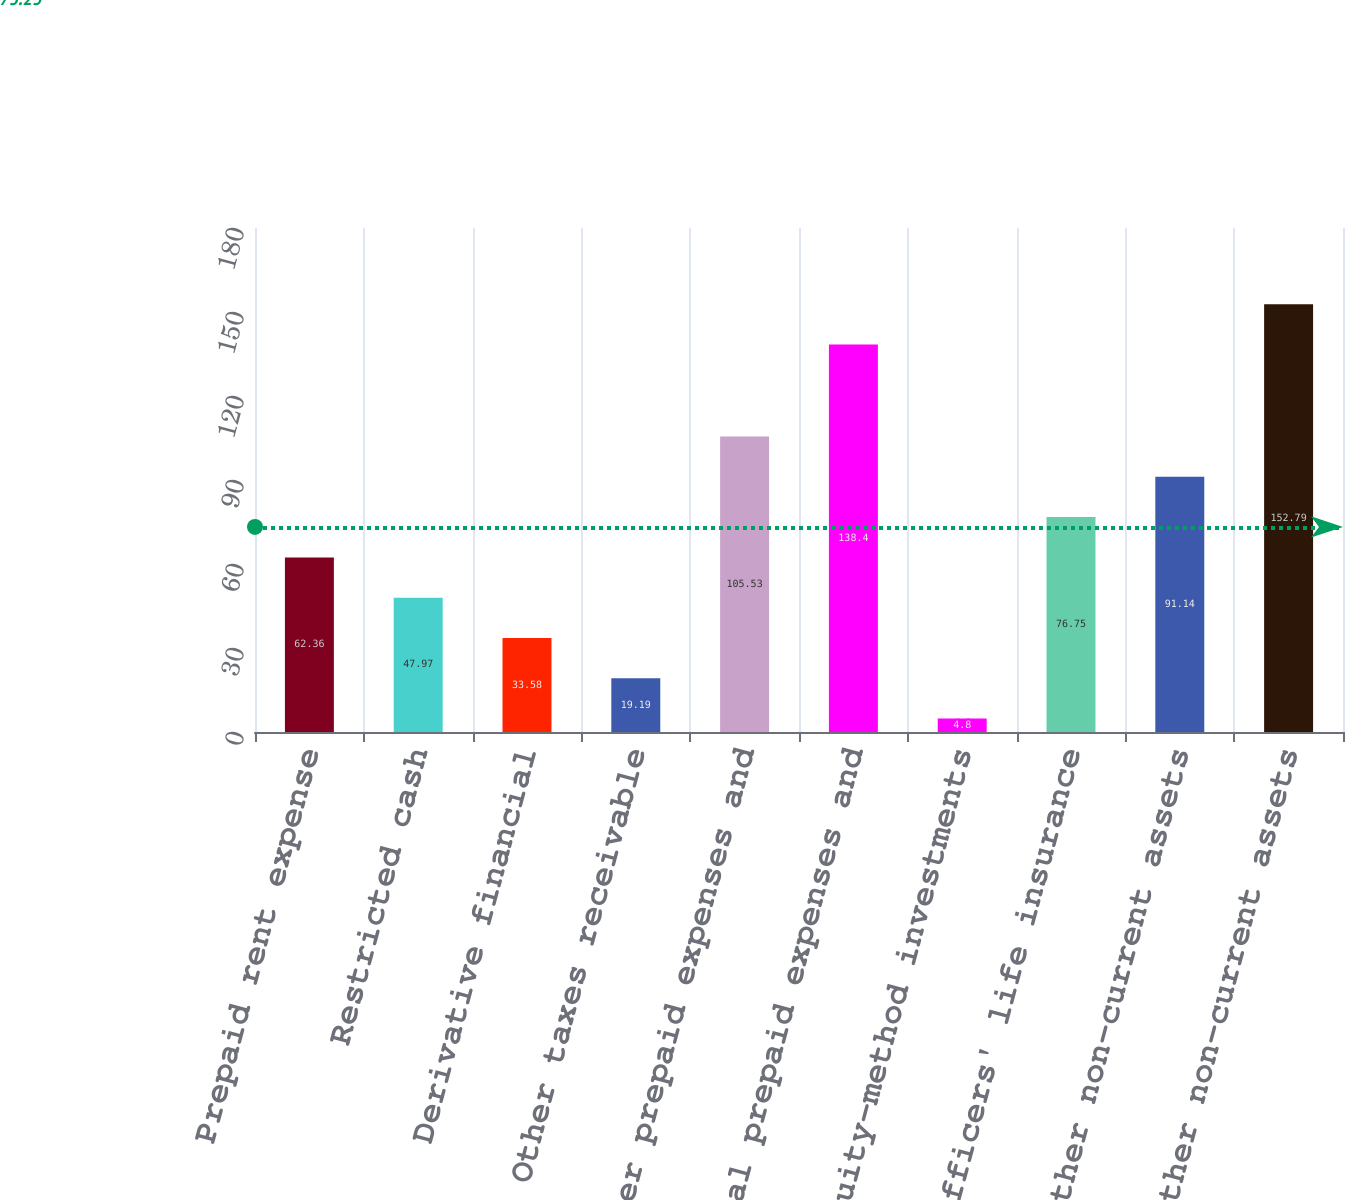Convert chart to OTSL. <chart><loc_0><loc_0><loc_500><loc_500><bar_chart><fcel>Prepaid rent expense<fcel>Restricted cash<fcel>Derivative financial<fcel>Other taxes receivable<fcel>Other prepaid expenses and<fcel>Total prepaid expenses and<fcel>Equity-method investments<fcel>Officers' life insurance<fcel>Other non-current assets<fcel>Total other non-current assets<nl><fcel>62.36<fcel>47.97<fcel>33.58<fcel>19.19<fcel>105.53<fcel>138.4<fcel>4.8<fcel>76.75<fcel>91.14<fcel>152.79<nl></chart> 